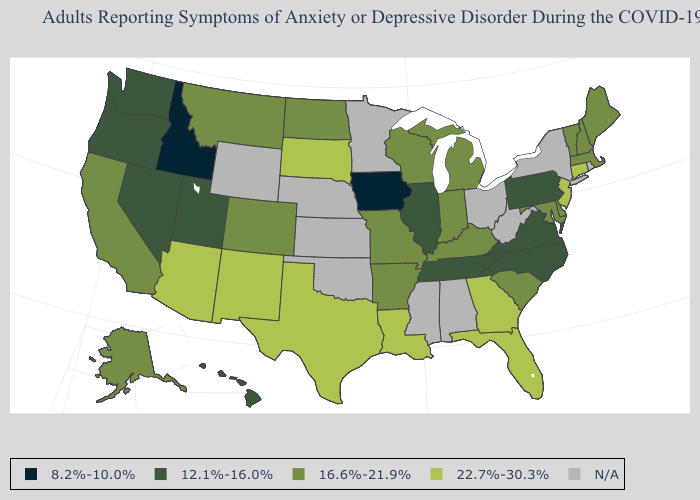What is the value of Delaware?
Write a very short answer. 16.6%-21.9%. What is the highest value in the Northeast ?
Quick response, please. 22.7%-30.3%. What is the value of Hawaii?
Be succinct. 12.1%-16.0%. Which states have the highest value in the USA?
Short answer required. Arizona, Connecticut, Florida, Georgia, Louisiana, New Jersey, New Mexico, South Dakota, Texas. What is the highest value in states that border Iowa?
Concise answer only. 22.7%-30.3%. Name the states that have a value in the range 22.7%-30.3%?
Keep it brief. Arizona, Connecticut, Florida, Georgia, Louisiana, New Jersey, New Mexico, South Dakota, Texas. What is the value of Arkansas?
Write a very short answer. 16.6%-21.9%. Name the states that have a value in the range N/A?
Answer briefly. Alabama, Kansas, Minnesota, Mississippi, Nebraska, New York, Ohio, Oklahoma, Rhode Island, West Virginia, Wyoming. Name the states that have a value in the range N/A?
Write a very short answer. Alabama, Kansas, Minnesota, Mississippi, Nebraska, New York, Ohio, Oklahoma, Rhode Island, West Virginia, Wyoming. What is the value of Nebraska?
Write a very short answer. N/A. What is the value of Texas?
Be succinct. 22.7%-30.3%. Among the states that border Maryland , which have the lowest value?
Quick response, please. Pennsylvania, Virginia. What is the value of Iowa?
Be succinct. 8.2%-10.0%. 